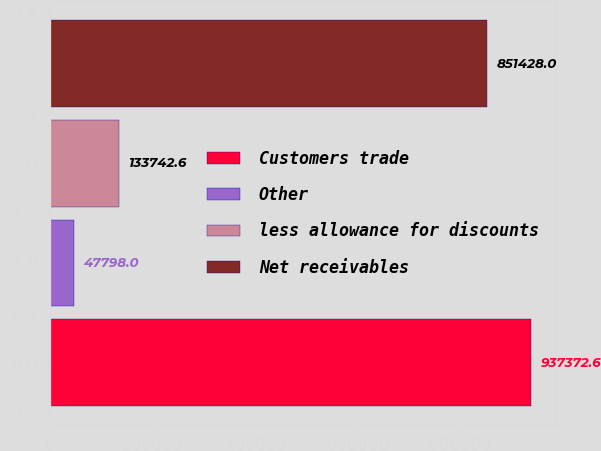Convert chart to OTSL. <chart><loc_0><loc_0><loc_500><loc_500><bar_chart><fcel>Customers trade<fcel>Other<fcel>less allowance for discounts<fcel>Net receivables<nl><fcel>937373<fcel>47798<fcel>133743<fcel>851428<nl></chart> 